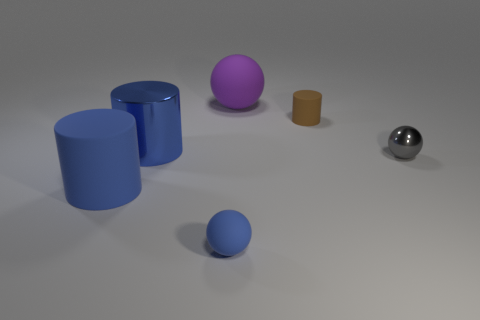Is the number of metal spheres that are in front of the tiny gray object the same as the number of tiny blue rubber objects on the left side of the blue metallic cylinder?
Keep it short and to the point. Yes. What number of blue matte things are the same shape as the small gray thing?
Offer a terse response. 1. Is there a red sphere that has the same material as the blue ball?
Give a very brief answer. No. The large object that is the same color as the big shiny cylinder is what shape?
Offer a terse response. Cylinder. How many big yellow rubber balls are there?
Make the answer very short. 0. What number of cylinders are gray objects or big purple things?
Your answer should be compact. 0. There is a matte cylinder that is the same size as the purple sphere; what is its color?
Offer a terse response. Blue. What number of matte things are both in front of the big shiny thing and right of the big blue metallic cylinder?
Provide a succinct answer. 1. What is the small brown cylinder made of?
Keep it short and to the point. Rubber. How many things are small spheres or matte spheres?
Provide a succinct answer. 3. 